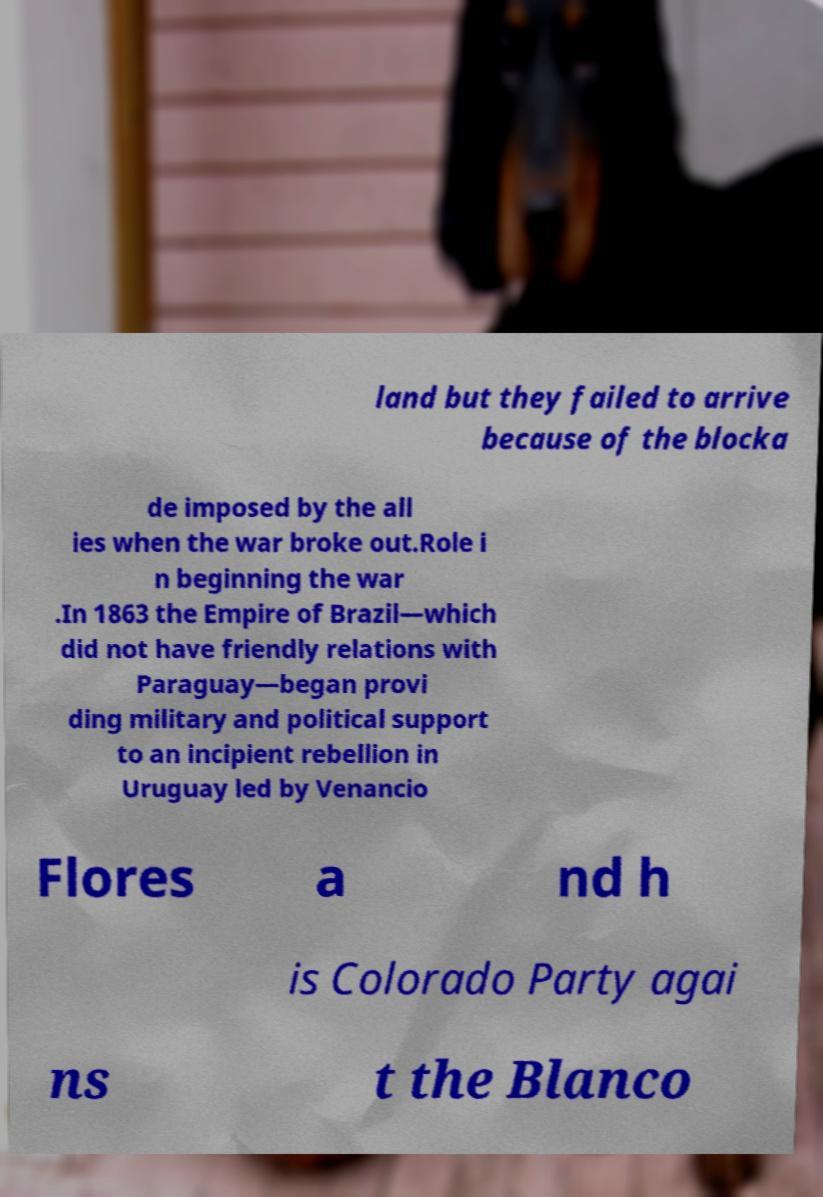There's text embedded in this image that I need extracted. Can you transcribe it verbatim? land but they failed to arrive because of the blocka de imposed by the all ies when the war broke out.Role i n beginning the war .In 1863 the Empire of Brazil—which did not have friendly relations with Paraguay—began provi ding military and political support to an incipient rebellion in Uruguay led by Venancio Flores a nd h is Colorado Party agai ns t the Blanco 